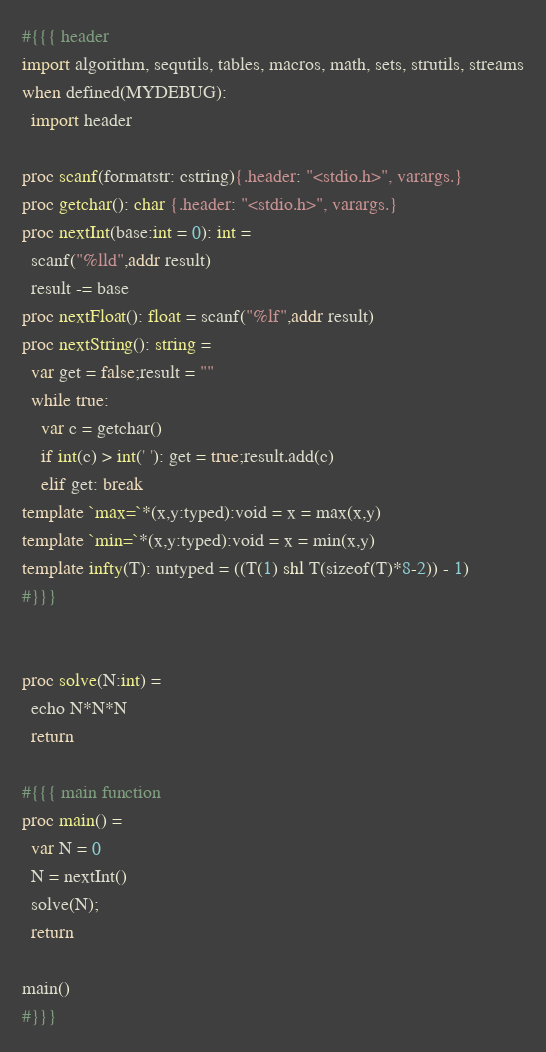<code> <loc_0><loc_0><loc_500><loc_500><_Nim_>#{{{ header
import algorithm, sequtils, tables, macros, math, sets, strutils, streams
when defined(MYDEBUG):
  import header

proc scanf(formatstr: cstring){.header: "<stdio.h>", varargs.}
proc getchar(): char {.header: "<stdio.h>", varargs.}
proc nextInt(base:int = 0): int =
  scanf("%lld",addr result)
  result -= base
proc nextFloat(): float = scanf("%lf",addr result)
proc nextString(): string =
  var get = false;result = ""
  while true:
    var c = getchar()
    if int(c) > int(' '): get = true;result.add(c)
    elif get: break
template `max=`*(x,y:typed):void = x = max(x,y)
template `min=`*(x,y:typed):void = x = min(x,y)
template infty(T): untyped = ((T(1) shl T(sizeof(T)*8-2)) - 1)
#}}}


proc solve(N:int) =
  echo N*N*N
  return

#{{{ main function
proc main() =
  var N = 0
  N = nextInt()
  solve(N);
  return

main()
#}}}
</code> 